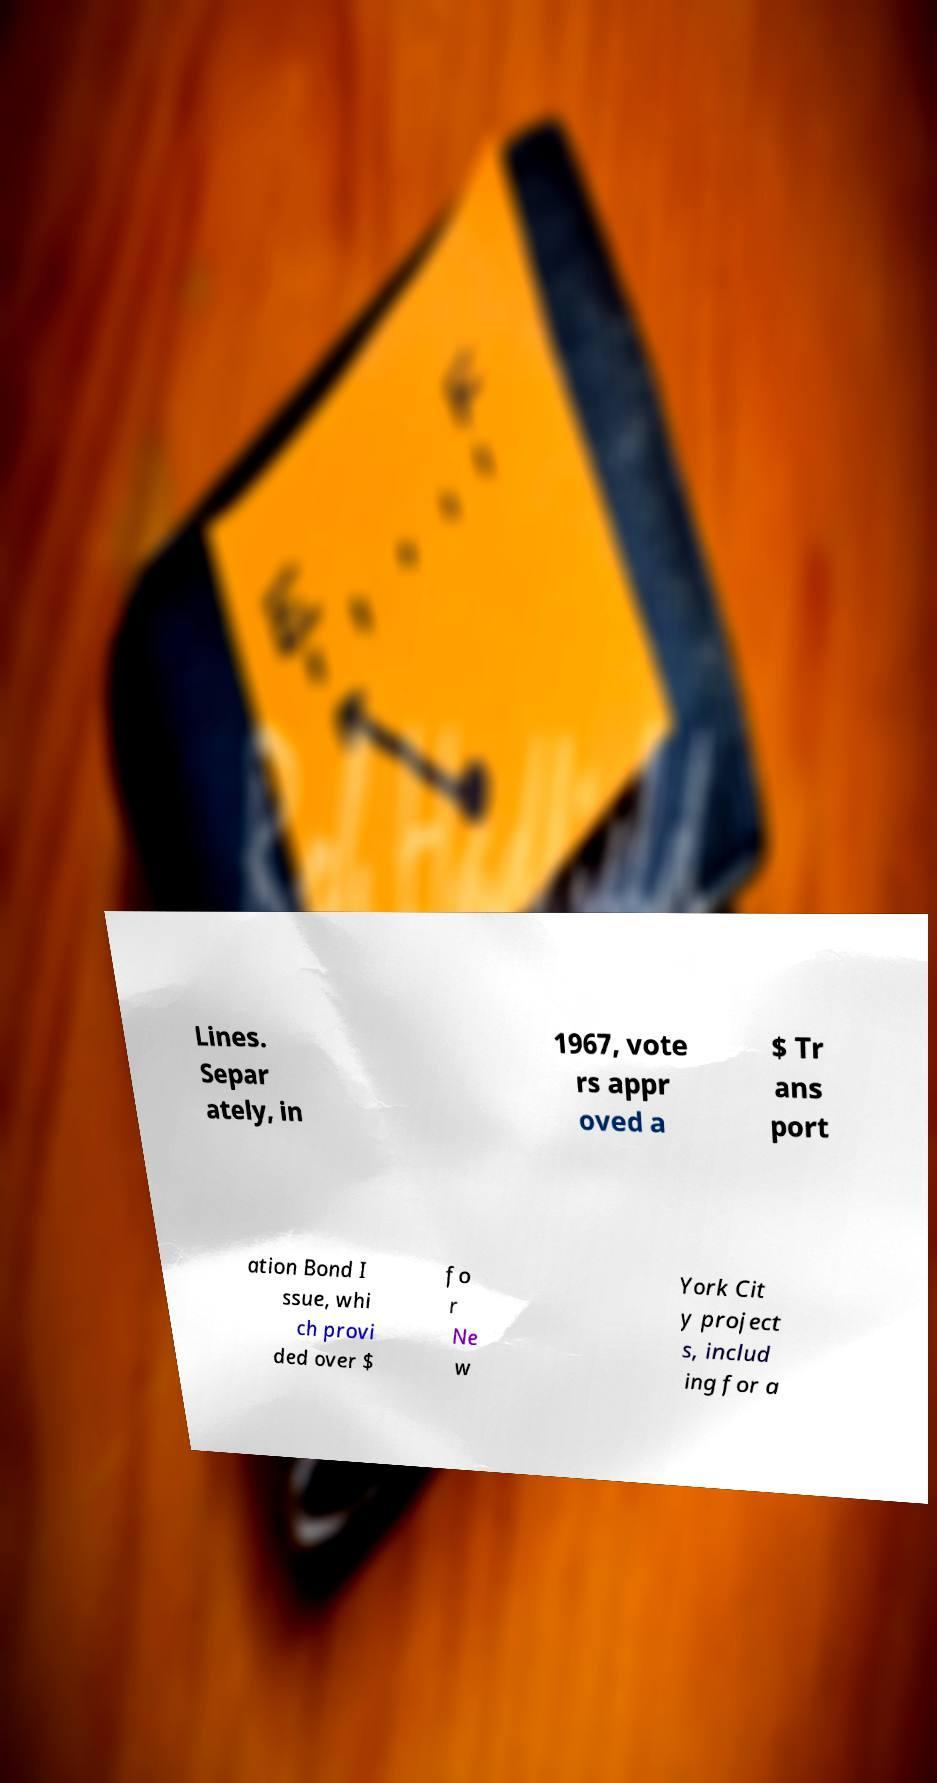What messages or text are displayed in this image? I need them in a readable, typed format. Lines. Separ ately, in 1967, vote rs appr oved a $ Tr ans port ation Bond I ssue, whi ch provi ded over $ fo r Ne w York Cit y project s, includ ing for a 